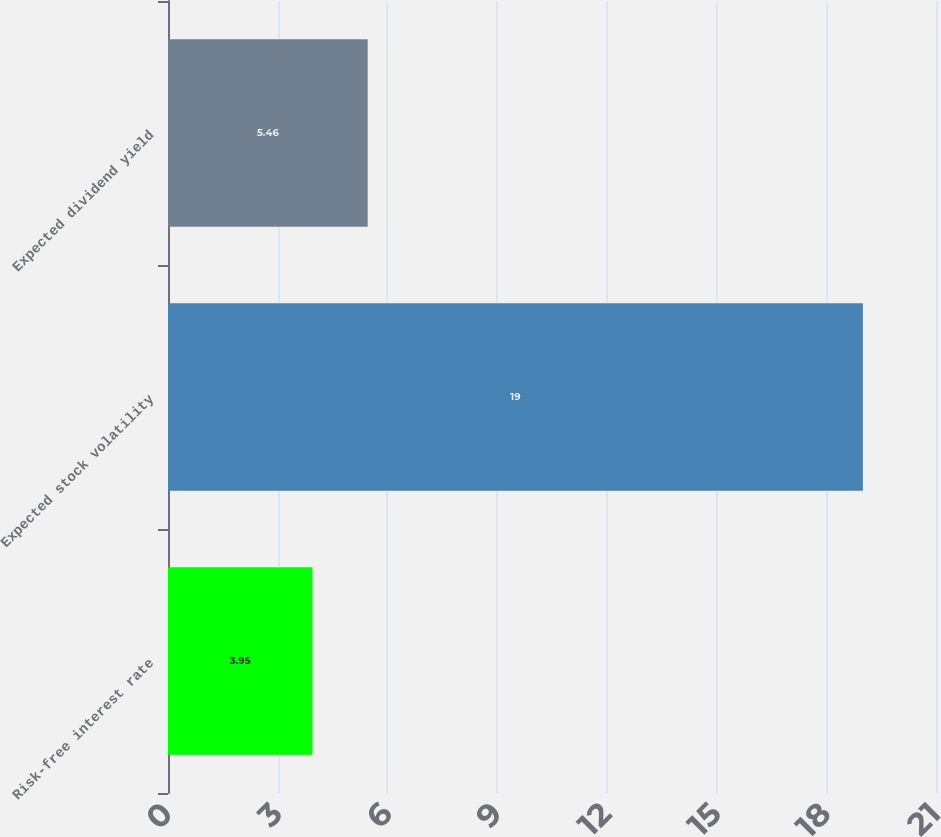Convert chart. <chart><loc_0><loc_0><loc_500><loc_500><bar_chart><fcel>Risk-free interest rate<fcel>Expected stock volatility<fcel>Expected dividend yield<nl><fcel>3.95<fcel>19<fcel>5.46<nl></chart> 